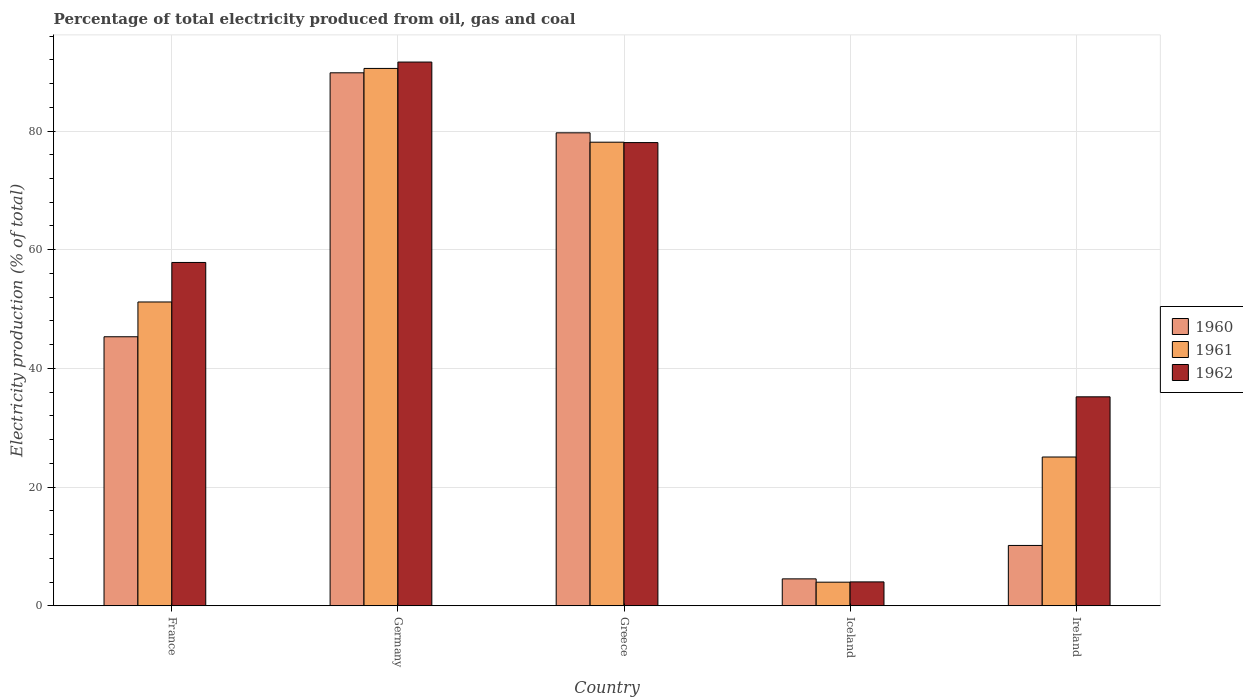Are the number of bars on each tick of the X-axis equal?
Your response must be concise. Yes. How many bars are there on the 5th tick from the left?
Give a very brief answer. 3. What is the label of the 5th group of bars from the left?
Keep it short and to the point. Ireland. In how many cases, is the number of bars for a given country not equal to the number of legend labels?
Give a very brief answer. 0. What is the electricity production in in 1961 in Ireland?
Your answer should be compact. 25.07. Across all countries, what is the maximum electricity production in in 1960?
Give a very brief answer. 89.81. Across all countries, what is the minimum electricity production in in 1960?
Give a very brief answer. 4.54. In which country was the electricity production in in 1962 minimum?
Your answer should be very brief. Iceland. What is the total electricity production in in 1962 in the graph?
Make the answer very short. 266.76. What is the difference between the electricity production in in 1962 in Greece and that in Iceland?
Keep it short and to the point. 74.02. What is the difference between the electricity production in in 1960 in Ireland and the electricity production in in 1961 in Iceland?
Offer a very short reply. 6.19. What is the average electricity production in in 1961 per country?
Ensure brevity in your answer.  49.78. What is the difference between the electricity production in of/in 1962 and electricity production in of/in 1961 in France?
Provide a succinct answer. 6.66. In how many countries, is the electricity production in in 1962 greater than 64 %?
Ensure brevity in your answer.  2. What is the ratio of the electricity production in in 1961 in France to that in Greece?
Provide a succinct answer. 0.66. What is the difference between the highest and the second highest electricity production in in 1960?
Ensure brevity in your answer.  44.48. What is the difference between the highest and the lowest electricity production in in 1962?
Ensure brevity in your answer.  87.59. What does the 2nd bar from the right in Germany represents?
Provide a short and direct response. 1961. Is it the case that in every country, the sum of the electricity production in in 1961 and electricity production in in 1962 is greater than the electricity production in in 1960?
Offer a terse response. Yes. What is the difference between two consecutive major ticks on the Y-axis?
Give a very brief answer. 20. Are the values on the major ticks of Y-axis written in scientific E-notation?
Give a very brief answer. No. Does the graph contain grids?
Your answer should be very brief. Yes. How many legend labels are there?
Keep it short and to the point. 3. What is the title of the graph?
Provide a succinct answer. Percentage of total electricity produced from oil, gas and coal. Does "1979" appear as one of the legend labels in the graph?
Offer a terse response. No. What is the label or title of the X-axis?
Provide a succinct answer. Country. What is the label or title of the Y-axis?
Your response must be concise. Electricity production (% of total). What is the Electricity production (% of total) of 1960 in France?
Give a very brief answer. 45.33. What is the Electricity production (% of total) of 1961 in France?
Give a very brief answer. 51.19. What is the Electricity production (% of total) of 1962 in France?
Provide a succinct answer. 57.85. What is the Electricity production (% of total) of 1960 in Germany?
Make the answer very short. 89.81. What is the Electricity production (% of total) of 1961 in Germany?
Provide a succinct answer. 90.54. What is the Electricity production (% of total) of 1962 in Germany?
Your answer should be compact. 91.62. What is the Electricity production (% of total) in 1960 in Greece?
Your response must be concise. 79.69. What is the Electricity production (% of total) of 1961 in Greece?
Provide a succinct answer. 78.12. What is the Electricity production (% of total) in 1962 in Greece?
Your answer should be compact. 78.05. What is the Electricity production (% of total) in 1960 in Iceland?
Ensure brevity in your answer.  4.54. What is the Electricity production (% of total) in 1961 in Iceland?
Provide a short and direct response. 3.98. What is the Electricity production (% of total) in 1962 in Iceland?
Provide a short and direct response. 4.03. What is the Electricity production (% of total) of 1960 in Ireland?
Ensure brevity in your answer.  10.17. What is the Electricity production (% of total) in 1961 in Ireland?
Your answer should be compact. 25.07. What is the Electricity production (% of total) of 1962 in Ireland?
Keep it short and to the point. 35.21. Across all countries, what is the maximum Electricity production (% of total) of 1960?
Ensure brevity in your answer.  89.81. Across all countries, what is the maximum Electricity production (% of total) of 1961?
Provide a succinct answer. 90.54. Across all countries, what is the maximum Electricity production (% of total) in 1962?
Offer a very short reply. 91.62. Across all countries, what is the minimum Electricity production (% of total) in 1960?
Make the answer very short. 4.54. Across all countries, what is the minimum Electricity production (% of total) of 1961?
Offer a terse response. 3.98. Across all countries, what is the minimum Electricity production (% of total) of 1962?
Keep it short and to the point. 4.03. What is the total Electricity production (% of total) of 1960 in the graph?
Offer a very short reply. 229.54. What is the total Electricity production (% of total) of 1961 in the graph?
Your response must be concise. 248.91. What is the total Electricity production (% of total) of 1962 in the graph?
Offer a terse response. 266.76. What is the difference between the Electricity production (% of total) in 1960 in France and that in Germany?
Offer a very short reply. -44.48. What is the difference between the Electricity production (% of total) of 1961 in France and that in Germany?
Make the answer very short. -39.35. What is the difference between the Electricity production (% of total) of 1962 in France and that in Germany?
Provide a succinct answer. -33.77. What is the difference between the Electricity production (% of total) of 1960 in France and that in Greece?
Your answer should be compact. -34.36. What is the difference between the Electricity production (% of total) of 1961 in France and that in Greece?
Keep it short and to the point. -26.92. What is the difference between the Electricity production (% of total) of 1962 in France and that in Greece?
Make the answer very short. -20.2. What is the difference between the Electricity production (% of total) in 1960 in France and that in Iceland?
Your answer should be compact. 40.8. What is the difference between the Electricity production (% of total) of 1961 in France and that in Iceland?
Offer a terse response. 47.21. What is the difference between the Electricity production (% of total) in 1962 in France and that in Iceland?
Keep it short and to the point. 53.83. What is the difference between the Electricity production (% of total) in 1960 in France and that in Ireland?
Offer a very short reply. 35.16. What is the difference between the Electricity production (% of total) of 1961 in France and that in Ireland?
Make the answer very short. 26.12. What is the difference between the Electricity production (% of total) in 1962 in France and that in Ireland?
Provide a succinct answer. 22.64. What is the difference between the Electricity production (% of total) of 1960 in Germany and that in Greece?
Your answer should be compact. 10.11. What is the difference between the Electricity production (% of total) of 1961 in Germany and that in Greece?
Your answer should be very brief. 12.43. What is the difference between the Electricity production (% of total) in 1962 in Germany and that in Greece?
Offer a terse response. 13.57. What is the difference between the Electricity production (% of total) of 1960 in Germany and that in Iceland?
Give a very brief answer. 85.27. What is the difference between the Electricity production (% of total) in 1961 in Germany and that in Iceland?
Provide a succinct answer. 86.56. What is the difference between the Electricity production (% of total) in 1962 in Germany and that in Iceland?
Make the answer very short. 87.59. What is the difference between the Electricity production (% of total) of 1960 in Germany and that in Ireland?
Provide a succinct answer. 79.64. What is the difference between the Electricity production (% of total) of 1961 in Germany and that in Ireland?
Offer a terse response. 65.47. What is the difference between the Electricity production (% of total) of 1962 in Germany and that in Ireland?
Your answer should be very brief. 56.41. What is the difference between the Electricity production (% of total) of 1960 in Greece and that in Iceland?
Your response must be concise. 75.16. What is the difference between the Electricity production (% of total) in 1961 in Greece and that in Iceland?
Make the answer very short. 74.14. What is the difference between the Electricity production (% of total) of 1962 in Greece and that in Iceland?
Provide a succinct answer. 74.02. What is the difference between the Electricity production (% of total) in 1960 in Greece and that in Ireland?
Offer a terse response. 69.53. What is the difference between the Electricity production (% of total) of 1961 in Greece and that in Ireland?
Your answer should be compact. 53.05. What is the difference between the Electricity production (% of total) in 1962 in Greece and that in Ireland?
Your response must be concise. 42.84. What is the difference between the Electricity production (% of total) in 1960 in Iceland and that in Ireland?
Provide a succinct answer. -5.63. What is the difference between the Electricity production (% of total) of 1961 in Iceland and that in Ireland?
Offer a terse response. -21.09. What is the difference between the Electricity production (% of total) in 1962 in Iceland and that in Ireland?
Provide a short and direct response. -31.19. What is the difference between the Electricity production (% of total) of 1960 in France and the Electricity production (% of total) of 1961 in Germany?
Make the answer very short. -45.21. What is the difference between the Electricity production (% of total) of 1960 in France and the Electricity production (% of total) of 1962 in Germany?
Give a very brief answer. -46.29. What is the difference between the Electricity production (% of total) in 1961 in France and the Electricity production (% of total) in 1962 in Germany?
Make the answer very short. -40.43. What is the difference between the Electricity production (% of total) of 1960 in France and the Electricity production (% of total) of 1961 in Greece?
Provide a short and direct response. -32.78. What is the difference between the Electricity production (% of total) in 1960 in France and the Electricity production (% of total) in 1962 in Greece?
Offer a very short reply. -32.72. What is the difference between the Electricity production (% of total) of 1961 in France and the Electricity production (% of total) of 1962 in Greece?
Provide a succinct answer. -26.86. What is the difference between the Electricity production (% of total) in 1960 in France and the Electricity production (% of total) in 1961 in Iceland?
Provide a succinct answer. 41.35. What is the difference between the Electricity production (% of total) of 1960 in France and the Electricity production (% of total) of 1962 in Iceland?
Your response must be concise. 41.31. What is the difference between the Electricity production (% of total) in 1961 in France and the Electricity production (% of total) in 1962 in Iceland?
Make the answer very short. 47.17. What is the difference between the Electricity production (% of total) in 1960 in France and the Electricity production (% of total) in 1961 in Ireland?
Your response must be concise. 20.26. What is the difference between the Electricity production (% of total) in 1960 in France and the Electricity production (% of total) in 1962 in Ireland?
Ensure brevity in your answer.  10.12. What is the difference between the Electricity production (% of total) in 1961 in France and the Electricity production (% of total) in 1962 in Ireland?
Make the answer very short. 15.98. What is the difference between the Electricity production (% of total) of 1960 in Germany and the Electricity production (% of total) of 1961 in Greece?
Ensure brevity in your answer.  11.69. What is the difference between the Electricity production (% of total) in 1960 in Germany and the Electricity production (% of total) in 1962 in Greece?
Keep it short and to the point. 11.76. What is the difference between the Electricity production (% of total) in 1961 in Germany and the Electricity production (% of total) in 1962 in Greece?
Give a very brief answer. 12.49. What is the difference between the Electricity production (% of total) in 1960 in Germany and the Electricity production (% of total) in 1961 in Iceland?
Provide a short and direct response. 85.83. What is the difference between the Electricity production (% of total) in 1960 in Germany and the Electricity production (% of total) in 1962 in Iceland?
Offer a very short reply. 85.78. What is the difference between the Electricity production (% of total) of 1961 in Germany and the Electricity production (% of total) of 1962 in Iceland?
Keep it short and to the point. 86.52. What is the difference between the Electricity production (% of total) of 1960 in Germany and the Electricity production (% of total) of 1961 in Ireland?
Provide a succinct answer. 64.74. What is the difference between the Electricity production (% of total) of 1960 in Germany and the Electricity production (% of total) of 1962 in Ireland?
Your answer should be compact. 54.6. What is the difference between the Electricity production (% of total) in 1961 in Germany and the Electricity production (% of total) in 1962 in Ireland?
Your answer should be compact. 55.33. What is the difference between the Electricity production (% of total) in 1960 in Greece and the Electricity production (% of total) in 1961 in Iceland?
Provide a short and direct response. 75.71. What is the difference between the Electricity production (% of total) in 1960 in Greece and the Electricity production (% of total) in 1962 in Iceland?
Provide a succinct answer. 75.67. What is the difference between the Electricity production (% of total) of 1961 in Greece and the Electricity production (% of total) of 1962 in Iceland?
Ensure brevity in your answer.  74.09. What is the difference between the Electricity production (% of total) of 1960 in Greece and the Electricity production (% of total) of 1961 in Ireland?
Keep it short and to the point. 54.62. What is the difference between the Electricity production (% of total) of 1960 in Greece and the Electricity production (% of total) of 1962 in Ireland?
Keep it short and to the point. 44.48. What is the difference between the Electricity production (% of total) of 1961 in Greece and the Electricity production (% of total) of 1962 in Ireland?
Offer a very short reply. 42.91. What is the difference between the Electricity production (% of total) in 1960 in Iceland and the Electricity production (% of total) in 1961 in Ireland?
Offer a terse response. -20.53. What is the difference between the Electricity production (% of total) of 1960 in Iceland and the Electricity production (% of total) of 1962 in Ireland?
Make the answer very short. -30.67. What is the difference between the Electricity production (% of total) of 1961 in Iceland and the Electricity production (% of total) of 1962 in Ireland?
Keep it short and to the point. -31.23. What is the average Electricity production (% of total) in 1960 per country?
Your answer should be very brief. 45.91. What is the average Electricity production (% of total) in 1961 per country?
Offer a very short reply. 49.78. What is the average Electricity production (% of total) of 1962 per country?
Offer a terse response. 53.35. What is the difference between the Electricity production (% of total) in 1960 and Electricity production (% of total) in 1961 in France?
Keep it short and to the point. -5.86. What is the difference between the Electricity production (% of total) in 1960 and Electricity production (% of total) in 1962 in France?
Your answer should be very brief. -12.52. What is the difference between the Electricity production (% of total) in 1961 and Electricity production (% of total) in 1962 in France?
Provide a succinct answer. -6.66. What is the difference between the Electricity production (% of total) of 1960 and Electricity production (% of total) of 1961 in Germany?
Your answer should be very brief. -0.74. What is the difference between the Electricity production (% of total) in 1960 and Electricity production (% of total) in 1962 in Germany?
Your response must be concise. -1.81. What is the difference between the Electricity production (% of total) of 1961 and Electricity production (% of total) of 1962 in Germany?
Ensure brevity in your answer.  -1.07. What is the difference between the Electricity production (% of total) of 1960 and Electricity production (% of total) of 1961 in Greece?
Provide a short and direct response. 1.58. What is the difference between the Electricity production (% of total) in 1960 and Electricity production (% of total) in 1962 in Greece?
Make the answer very short. 1.64. What is the difference between the Electricity production (% of total) of 1961 and Electricity production (% of total) of 1962 in Greece?
Offer a terse response. 0.07. What is the difference between the Electricity production (% of total) of 1960 and Electricity production (% of total) of 1961 in Iceland?
Offer a very short reply. 0.56. What is the difference between the Electricity production (% of total) of 1960 and Electricity production (% of total) of 1962 in Iceland?
Make the answer very short. 0.51. What is the difference between the Electricity production (% of total) in 1961 and Electricity production (% of total) in 1962 in Iceland?
Give a very brief answer. -0.05. What is the difference between the Electricity production (% of total) of 1960 and Electricity production (% of total) of 1961 in Ireland?
Make the answer very short. -14.9. What is the difference between the Electricity production (% of total) in 1960 and Electricity production (% of total) in 1962 in Ireland?
Offer a terse response. -25.04. What is the difference between the Electricity production (% of total) in 1961 and Electricity production (% of total) in 1962 in Ireland?
Ensure brevity in your answer.  -10.14. What is the ratio of the Electricity production (% of total) in 1960 in France to that in Germany?
Provide a short and direct response. 0.5. What is the ratio of the Electricity production (% of total) of 1961 in France to that in Germany?
Your answer should be compact. 0.57. What is the ratio of the Electricity production (% of total) in 1962 in France to that in Germany?
Provide a short and direct response. 0.63. What is the ratio of the Electricity production (% of total) of 1960 in France to that in Greece?
Ensure brevity in your answer.  0.57. What is the ratio of the Electricity production (% of total) of 1961 in France to that in Greece?
Your answer should be compact. 0.66. What is the ratio of the Electricity production (% of total) of 1962 in France to that in Greece?
Keep it short and to the point. 0.74. What is the ratio of the Electricity production (% of total) in 1960 in France to that in Iceland?
Ensure brevity in your answer.  9.99. What is the ratio of the Electricity production (% of total) of 1961 in France to that in Iceland?
Provide a succinct answer. 12.86. What is the ratio of the Electricity production (% of total) in 1962 in France to that in Iceland?
Give a very brief answer. 14.37. What is the ratio of the Electricity production (% of total) of 1960 in France to that in Ireland?
Provide a succinct answer. 4.46. What is the ratio of the Electricity production (% of total) of 1961 in France to that in Ireland?
Ensure brevity in your answer.  2.04. What is the ratio of the Electricity production (% of total) in 1962 in France to that in Ireland?
Provide a short and direct response. 1.64. What is the ratio of the Electricity production (% of total) in 1960 in Germany to that in Greece?
Ensure brevity in your answer.  1.13. What is the ratio of the Electricity production (% of total) in 1961 in Germany to that in Greece?
Your answer should be compact. 1.16. What is the ratio of the Electricity production (% of total) of 1962 in Germany to that in Greece?
Your answer should be very brief. 1.17. What is the ratio of the Electricity production (% of total) of 1960 in Germany to that in Iceland?
Your answer should be very brief. 19.79. What is the ratio of the Electricity production (% of total) of 1961 in Germany to that in Iceland?
Ensure brevity in your answer.  22.75. What is the ratio of the Electricity production (% of total) of 1962 in Germany to that in Iceland?
Your answer should be compact. 22.76. What is the ratio of the Electricity production (% of total) in 1960 in Germany to that in Ireland?
Make the answer very short. 8.83. What is the ratio of the Electricity production (% of total) in 1961 in Germany to that in Ireland?
Give a very brief answer. 3.61. What is the ratio of the Electricity production (% of total) of 1962 in Germany to that in Ireland?
Give a very brief answer. 2.6. What is the ratio of the Electricity production (% of total) of 1960 in Greece to that in Iceland?
Your answer should be compact. 17.56. What is the ratio of the Electricity production (% of total) of 1961 in Greece to that in Iceland?
Provide a succinct answer. 19.63. What is the ratio of the Electricity production (% of total) in 1962 in Greece to that in Iceland?
Your answer should be very brief. 19.39. What is the ratio of the Electricity production (% of total) in 1960 in Greece to that in Ireland?
Make the answer very short. 7.84. What is the ratio of the Electricity production (% of total) in 1961 in Greece to that in Ireland?
Your answer should be compact. 3.12. What is the ratio of the Electricity production (% of total) of 1962 in Greece to that in Ireland?
Provide a succinct answer. 2.22. What is the ratio of the Electricity production (% of total) in 1960 in Iceland to that in Ireland?
Keep it short and to the point. 0.45. What is the ratio of the Electricity production (% of total) of 1961 in Iceland to that in Ireland?
Offer a very short reply. 0.16. What is the ratio of the Electricity production (% of total) in 1962 in Iceland to that in Ireland?
Ensure brevity in your answer.  0.11. What is the difference between the highest and the second highest Electricity production (% of total) in 1960?
Provide a succinct answer. 10.11. What is the difference between the highest and the second highest Electricity production (% of total) of 1961?
Your answer should be very brief. 12.43. What is the difference between the highest and the second highest Electricity production (% of total) in 1962?
Your answer should be compact. 13.57. What is the difference between the highest and the lowest Electricity production (% of total) of 1960?
Ensure brevity in your answer.  85.27. What is the difference between the highest and the lowest Electricity production (% of total) of 1961?
Make the answer very short. 86.56. What is the difference between the highest and the lowest Electricity production (% of total) in 1962?
Your response must be concise. 87.59. 